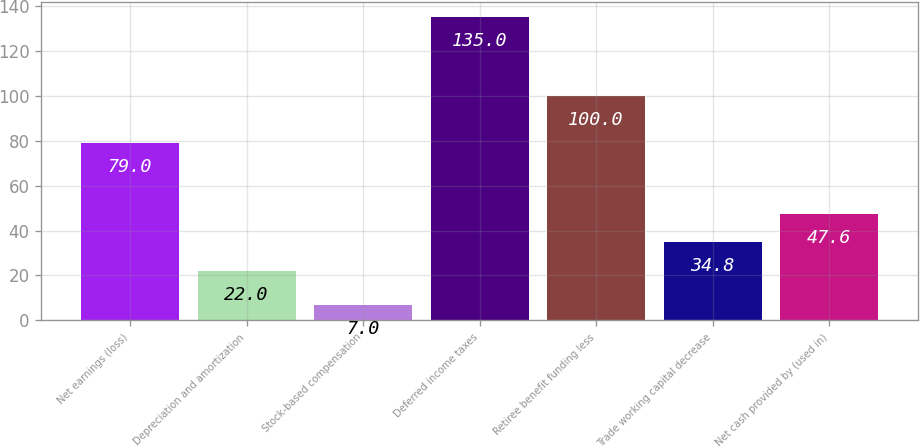<chart> <loc_0><loc_0><loc_500><loc_500><bar_chart><fcel>Net earnings (loss)<fcel>Depreciation and amortization<fcel>Stock-based compensation<fcel>Deferred income taxes<fcel>Retiree benefit funding less<fcel>Trade working capital decrease<fcel>Net cash provided by (used in)<nl><fcel>79<fcel>22<fcel>7<fcel>135<fcel>100<fcel>34.8<fcel>47.6<nl></chart> 